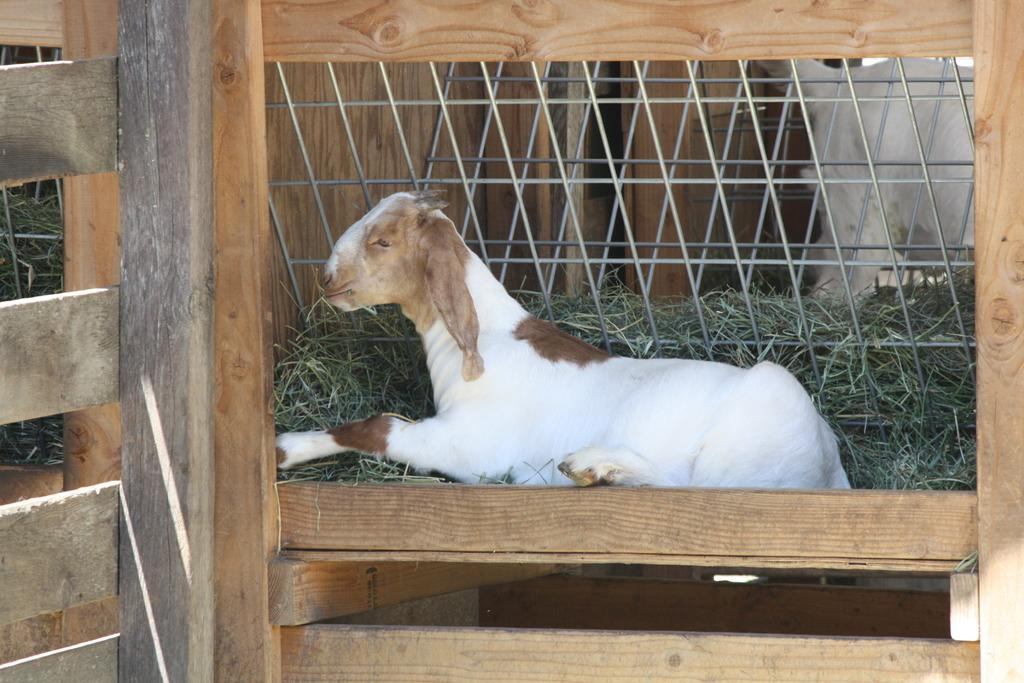What animal is present in the image? There is a goat in the image. Can you describe the color of the goat? The goat has a white and brown color. What type of vegetation can be seen in the image? There is grass visible in the image. What can be seen in the background of the image? There are metal rods in the background of the image. Reasoning: Let' Let's think step by step in order to produce the conversation. We start by identifying the main subject of the image, which is the goat. Then, we describe the color of the goat, as it is a notable feature. Next, we mention the vegetation present in the image, which is grass. Finally, we describe the background of the image, which includes metal rods. Each question is designed to elicit a specific detail about the image that is known from the provided facts. Absurd Question/Answer: Where is the nest located in the image? There is no nest present in the image. What type of pancake is the goat eating in the image? The goat is not eating a pancake in the image; it is grazing on grass. How many bananas are hanging from the metal rods in the background? There are no bananas present in the image, and the metal rods are not depicted as supporting any fruit. 